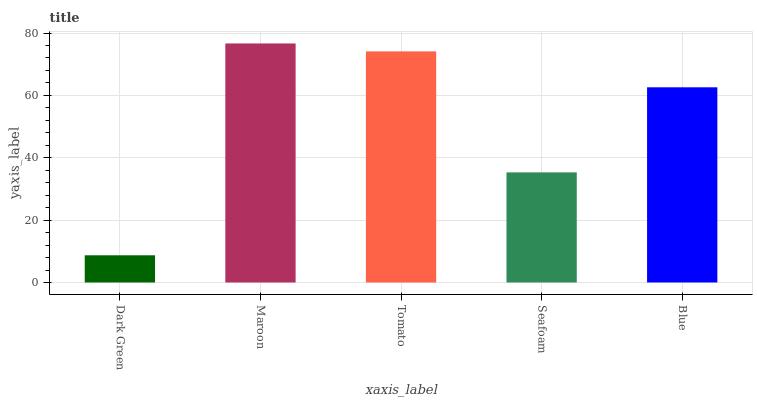Is Dark Green the minimum?
Answer yes or no. Yes. Is Maroon the maximum?
Answer yes or no. Yes. Is Tomato the minimum?
Answer yes or no. No. Is Tomato the maximum?
Answer yes or no. No. Is Maroon greater than Tomato?
Answer yes or no. Yes. Is Tomato less than Maroon?
Answer yes or no. Yes. Is Tomato greater than Maroon?
Answer yes or no. No. Is Maroon less than Tomato?
Answer yes or no. No. Is Blue the high median?
Answer yes or no. Yes. Is Blue the low median?
Answer yes or no. Yes. Is Seafoam the high median?
Answer yes or no. No. Is Seafoam the low median?
Answer yes or no. No. 